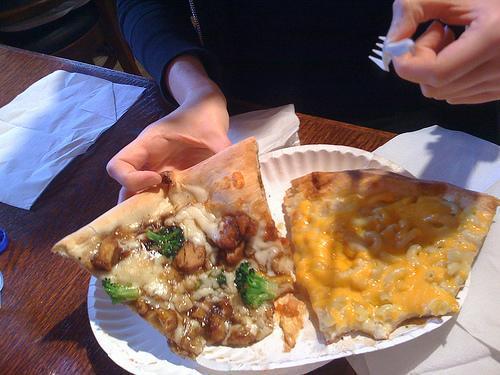How many slices of pizza do you see?
Give a very brief answer. 2. How many slices of pizza have broccoli?
Give a very brief answer. 1. 